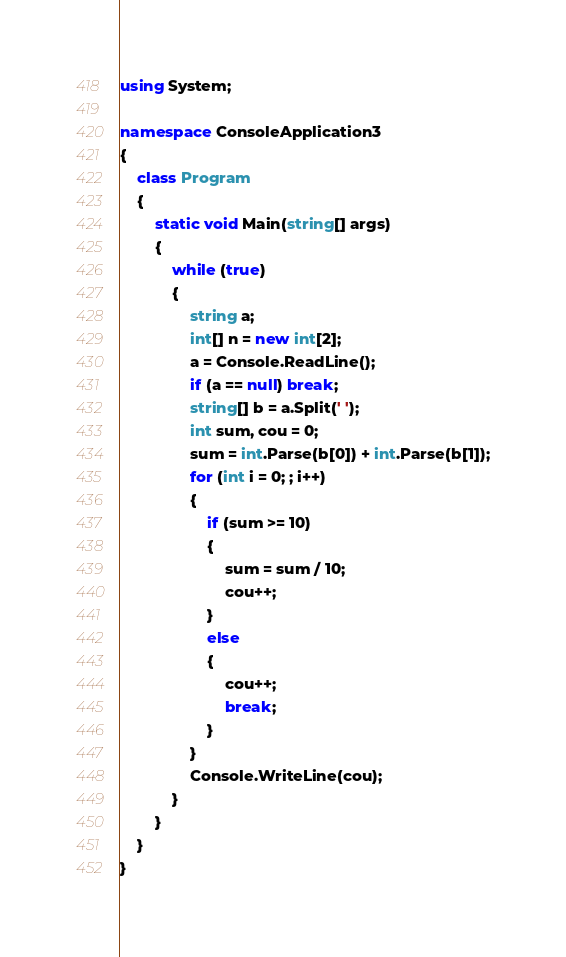Convert code to text. <code><loc_0><loc_0><loc_500><loc_500><_C#_>using System;

namespace ConsoleApplication3
{
    class Program
    {
        static void Main(string[] args)
        {
            while (true)
            {
                string a;
                int[] n = new int[2];
                a = Console.ReadLine();
                if (a == null) break;
                string[] b = a.Split(' ');
                int sum, cou = 0;
                sum = int.Parse(b[0]) + int.Parse(b[1]);
                for (int i = 0; ; i++)
                {
                    if (sum >= 10)
                    {
                        sum = sum / 10;
                        cou++;
                    }
                    else
                    {
                        cou++;
                        break;
                    }
                }
                Console.WriteLine(cou);
            }
        }
    }
}</code> 